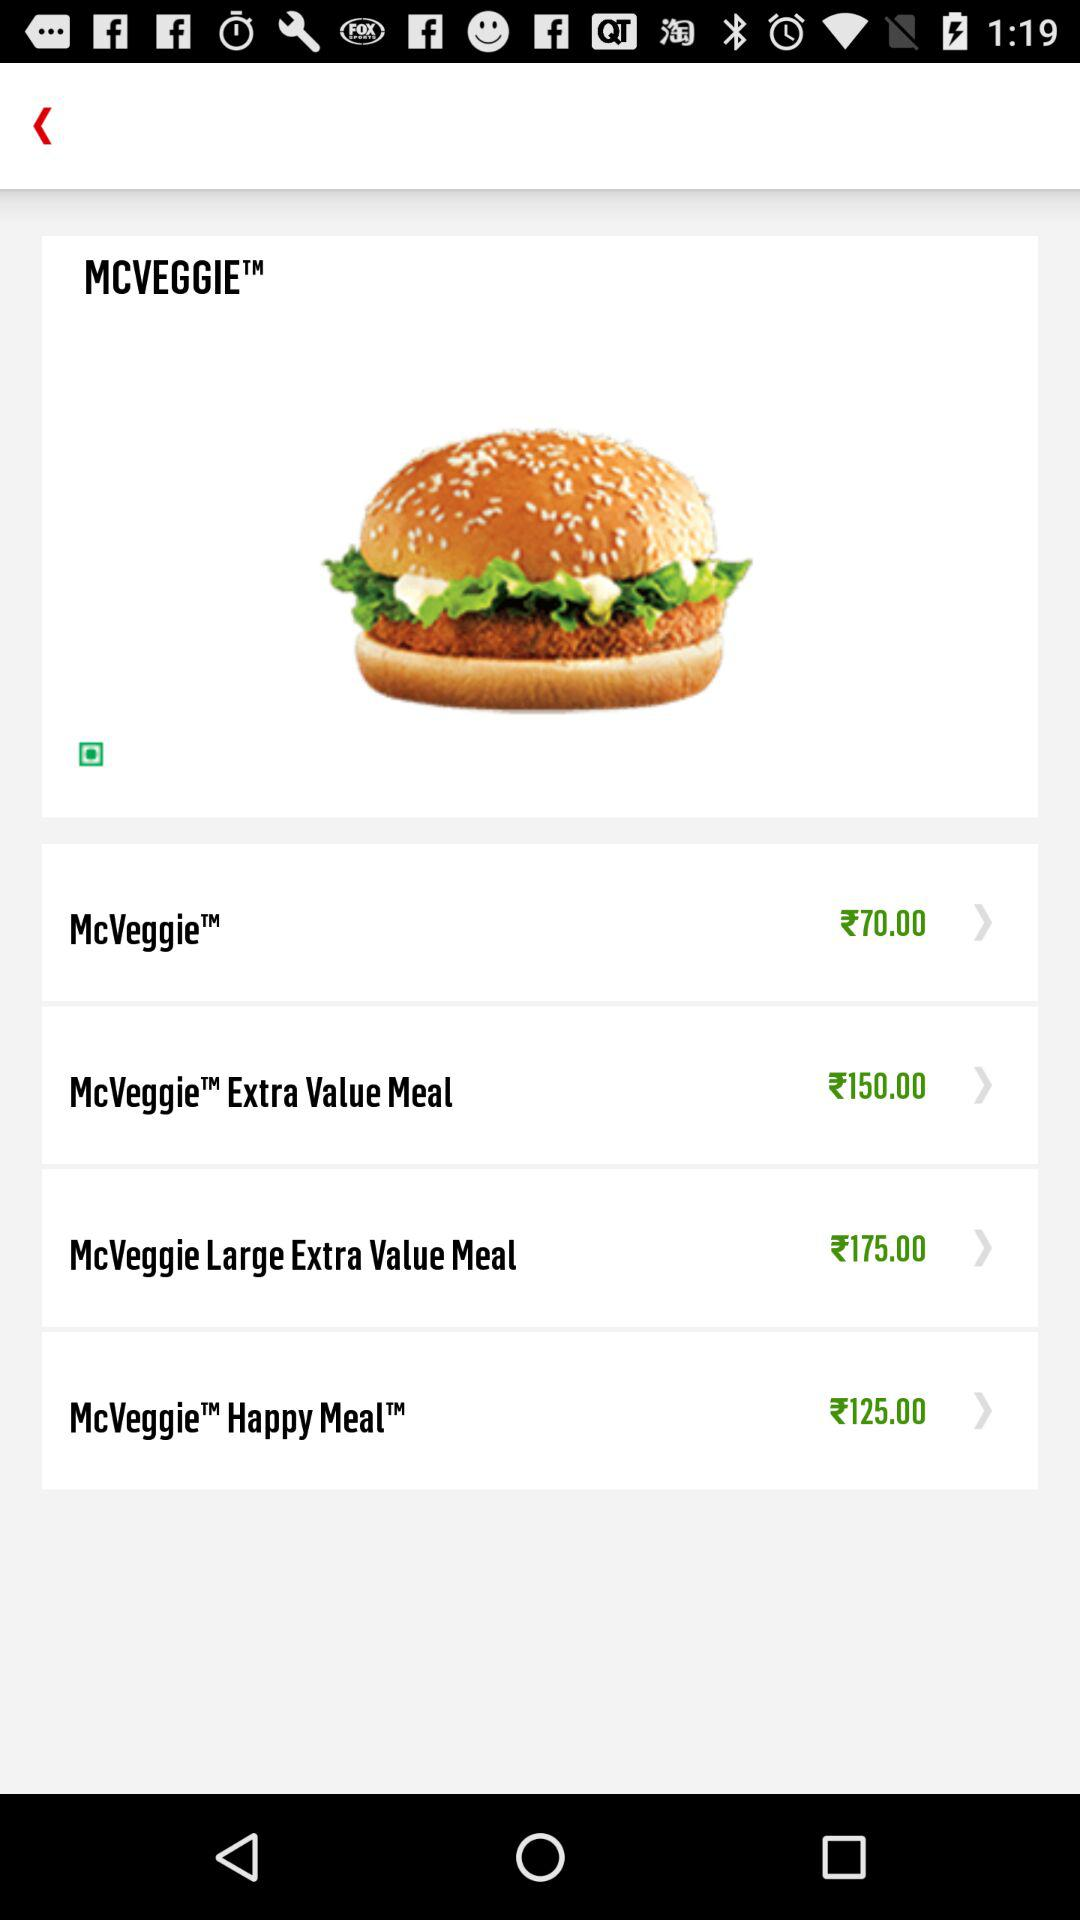What is the price of "McVeggie Extra Value Meal"? The price of "McVeggie Extra Value Meal" is ₹150.00. 